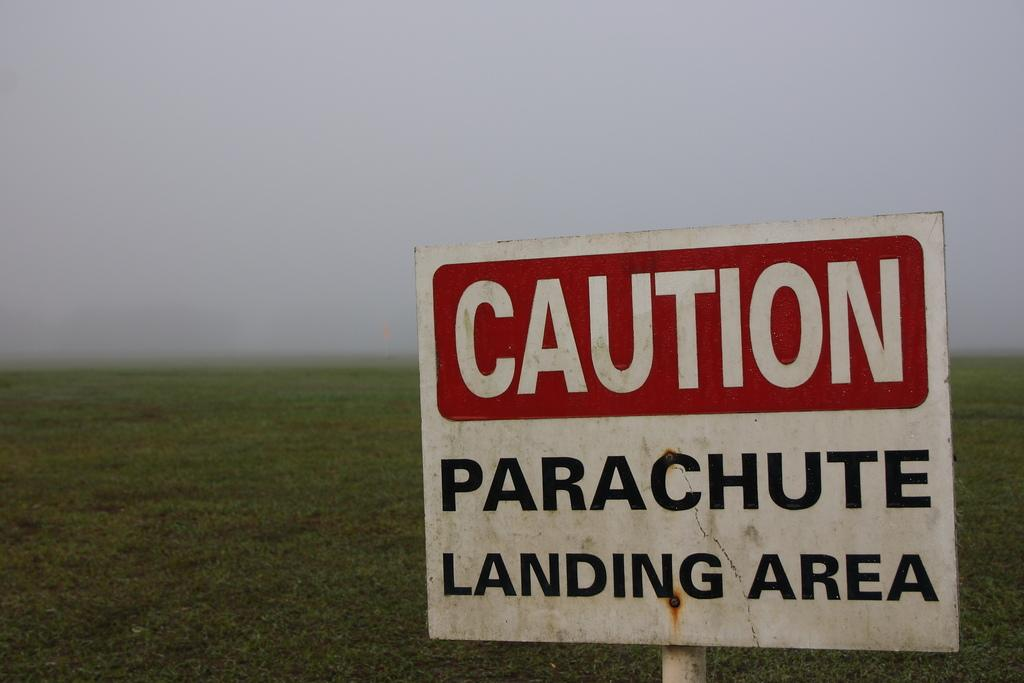What is the main object in the image? There is a board in the image. What is on the board? Words are written on the board. What type of environment is depicted in the image? There is grass visible in the image, suggesting an outdoor setting. How many books are stacked on the knee of the person in the image? There is no person or books present in the image, so this question cannot be answered. 